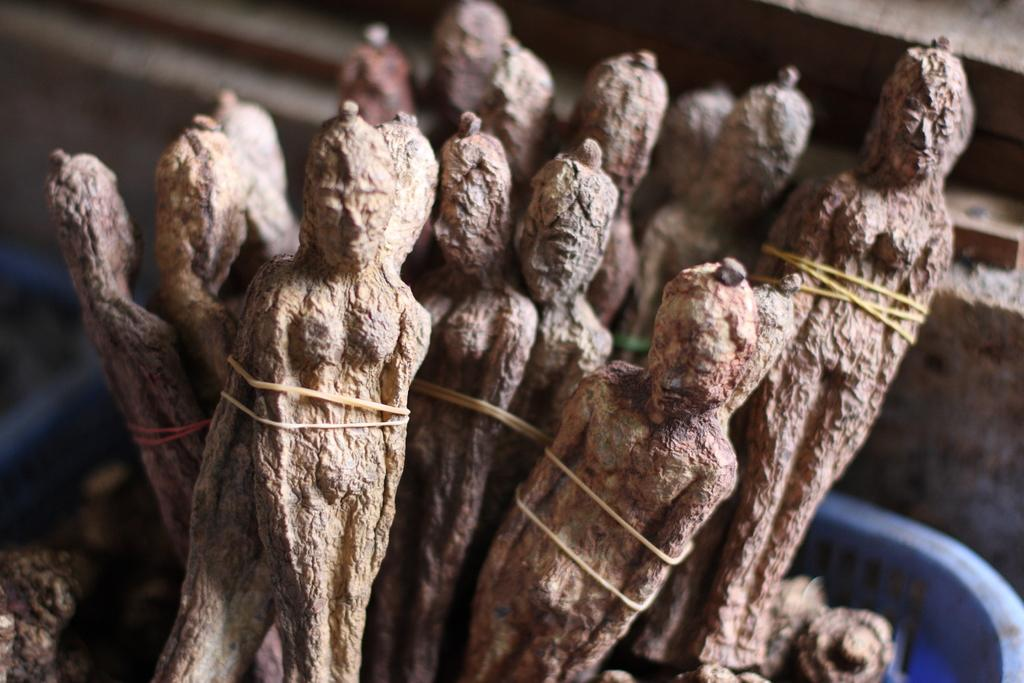What objects are in the tray in the image? There are sculptures in a tray in the image. Can you describe the background of the image? The background of the image is blurred. What type of mint can be seen growing near the sculptures in the image? There is no mint present in the image; it only features sculptures in a tray and a blurred background. 